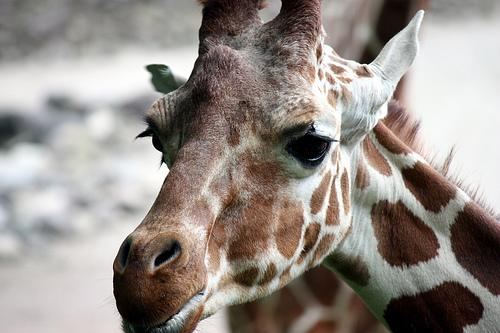Examine the image and provide a brief description of the giraffe's pose. The giraffe in the image appears to be looking straight ahead with a calm and attentive demeanor. Explain the overall sentiment projected by the image. The image projects a sense of curiosity and awe since it offers a close-up view of a giraffe's face, allowing viewers to appreciate its unique features. Perform a quick analysis of the visual context of the giraffe's facial features in the image. The giraffe's eyes are wide and bright, its nostrils are sizeable, and its ears are positioned up and outwards while its mouth appears relaxed, all contributing to the overall gentle and curious expression. Imagine a complex reasoning task that could stem from studying this image. Predicting the giraffe's behavior in the next few seconds based on subtle cues from its facial features, such as eye movements or ear positions, to determine if it's about to move or react to a nearby stimulus. Enumerate the distinct features of a giraffe present in the image. In the image, there are eyes, mouth, nose, ears, nostrils, eye lashes, neck, mane, horn, spots, and cheek of a giraffe featured. Describe the quality of the image in terms of the level of detail captured. The image is of high quality, capturing intricate details like eye lashes and spots on the giraffe's face, allowing for clear observation and appreciation of these features. Analyze the possible interaction between objects in the image. The image does not show enough context for object interaction, as the focus is mainly on the facial features of a single adult giraffe. What is the primary focus of the image? The primary focus of the image is a close-up of a giraffe's face, including its eyes, nose, mouth, ears, and other facial features. Count how many eyes, nostrils, and ears of a giraffe are shown in the photograph. There are two eyes, two nostrils, and two ears of a giraffe depicted in the image. 